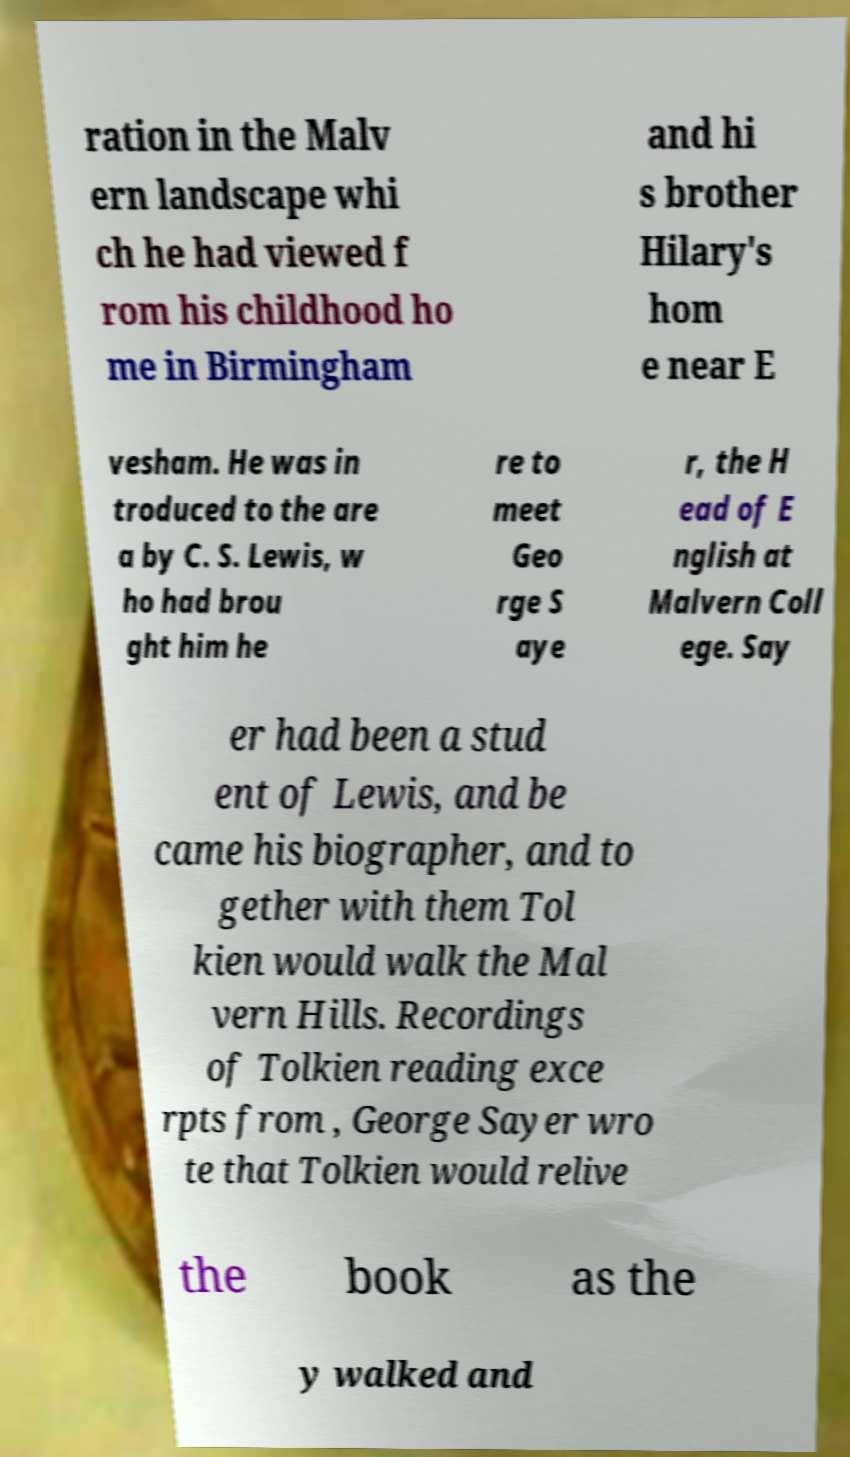Please identify and transcribe the text found in this image. ration in the Malv ern landscape whi ch he had viewed f rom his childhood ho me in Birmingham and hi s brother Hilary's hom e near E vesham. He was in troduced to the are a by C. S. Lewis, w ho had brou ght him he re to meet Geo rge S aye r, the H ead of E nglish at Malvern Coll ege. Say er had been a stud ent of Lewis, and be came his biographer, and to gether with them Tol kien would walk the Mal vern Hills. Recordings of Tolkien reading exce rpts from , George Sayer wro te that Tolkien would relive the book as the y walked and 